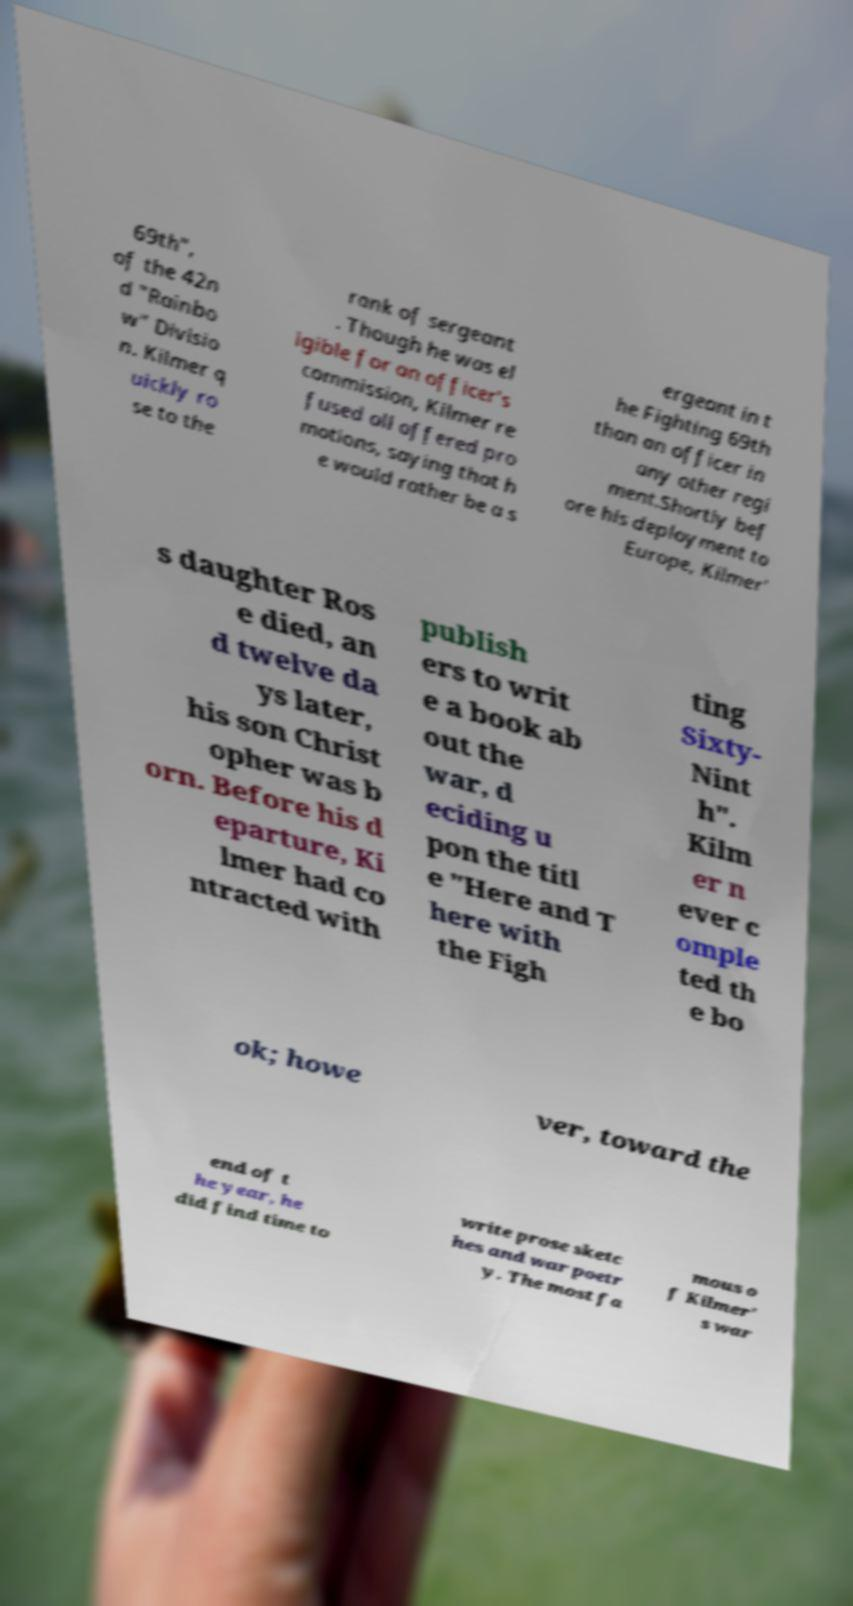For documentation purposes, I need the text within this image transcribed. Could you provide that? 69th", of the 42n d "Rainbo w" Divisio n. Kilmer q uickly ro se to the rank of sergeant . Though he was el igible for an officer's commission, Kilmer re fused all offered pro motions, saying that h e would rather be a s ergeant in t he Fighting 69th than an officer in any other regi ment.Shortly bef ore his deployment to Europe, Kilmer' s daughter Ros e died, an d twelve da ys later, his son Christ opher was b orn. Before his d eparture, Ki lmer had co ntracted with publish ers to writ e a book ab out the war, d eciding u pon the titl e "Here and T here with the Figh ting Sixty- Nint h". Kilm er n ever c omple ted th e bo ok; howe ver, toward the end of t he year, he did find time to write prose sketc hes and war poetr y. The most fa mous o f Kilmer' s war 